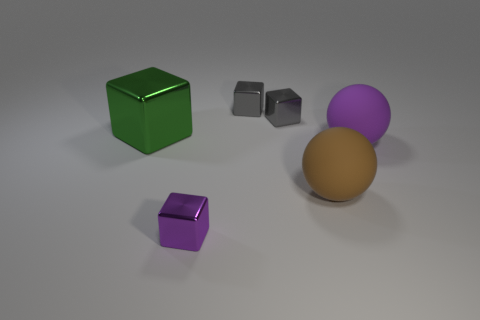Add 1 small yellow shiny spheres. How many objects exist? 7 Subtract all large green cubes. How many cubes are left? 3 Subtract 3 blocks. How many blocks are left? 1 Subtract all gray cubes. How many cubes are left? 2 Subtract all yellow balls. Subtract all yellow blocks. How many balls are left? 2 Subtract all yellow cylinders. How many cyan blocks are left? 0 Add 6 cubes. How many cubes exist? 10 Subtract 0 yellow cylinders. How many objects are left? 6 Subtract all spheres. How many objects are left? 4 Subtract all purple shiny blocks. Subtract all purple balls. How many objects are left? 4 